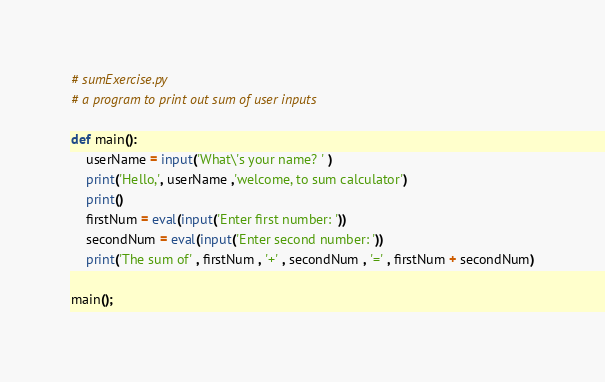Convert code to text. <code><loc_0><loc_0><loc_500><loc_500><_Python_># sumExercise.py
# a program to print out sum of user inputs

def main():
    userName = input('What\'s your name? ' )
    print('Hello,', userName ,'welcome, to sum calculator')
    print()
    firstNum = eval(input('Enter first number: '))
    secondNum = eval(input('Enter second number: '))
    print('The sum of' , firstNum , '+' , secondNum , '=' , firstNum + secondNum)
    
main();</code> 